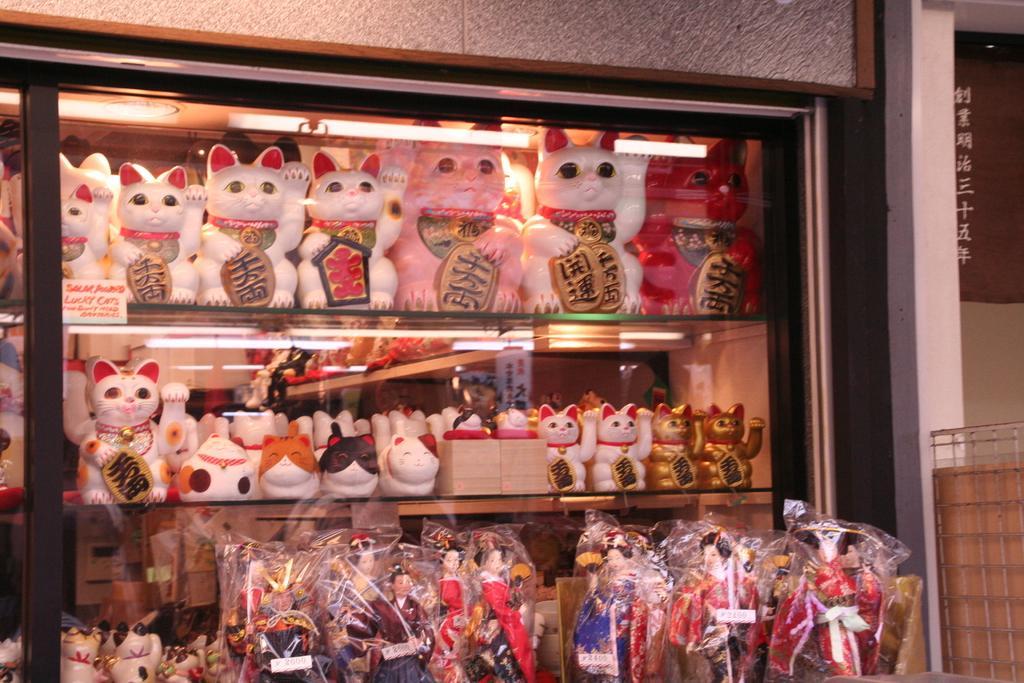In one or two sentences, can you explain what this image depicts? In this image I can see rack which is filled with the toys. On the right side, I can see the wall and railing. 